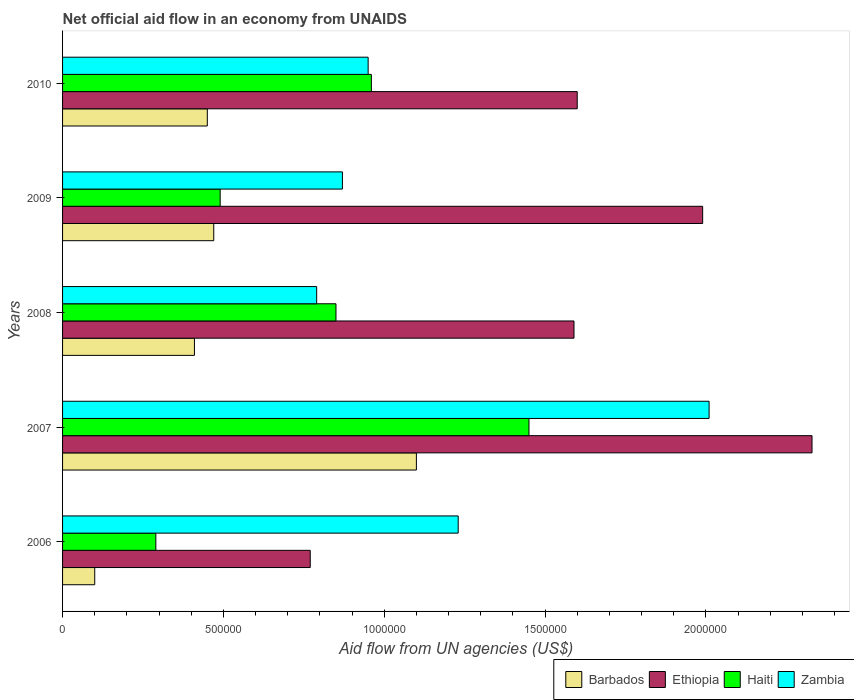How many different coloured bars are there?
Keep it short and to the point. 4. How many groups of bars are there?
Make the answer very short. 5. Are the number of bars on each tick of the Y-axis equal?
Your response must be concise. Yes. How many bars are there on the 1st tick from the bottom?
Your answer should be very brief. 4. What is the label of the 1st group of bars from the top?
Your response must be concise. 2010. What is the net official aid flow in Zambia in 2006?
Offer a very short reply. 1.23e+06. Across all years, what is the maximum net official aid flow in Barbados?
Make the answer very short. 1.10e+06. Across all years, what is the minimum net official aid flow in Zambia?
Provide a succinct answer. 7.90e+05. What is the total net official aid flow in Haiti in the graph?
Make the answer very short. 4.04e+06. What is the difference between the net official aid flow in Zambia in 2007 and that in 2008?
Ensure brevity in your answer.  1.22e+06. What is the difference between the net official aid flow in Ethiopia in 2009 and the net official aid flow in Zambia in 2007?
Your answer should be very brief. -2.00e+04. What is the average net official aid flow in Barbados per year?
Your answer should be compact. 5.06e+05. What is the ratio of the net official aid flow in Ethiopia in 2008 to that in 2009?
Your answer should be compact. 0.8. Is the difference between the net official aid flow in Haiti in 2009 and 2010 greater than the difference between the net official aid flow in Barbados in 2009 and 2010?
Your answer should be very brief. No. What is the difference between the highest and the second highest net official aid flow in Haiti?
Make the answer very short. 4.90e+05. What is the difference between the highest and the lowest net official aid flow in Ethiopia?
Keep it short and to the point. 1.56e+06. In how many years, is the net official aid flow in Ethiopia greater than the average net official aid flow in Ethiopia taken over all years?
Your answer should be very brief. 2. Is the sum of the net official aid flow in Barbados in 2006 and 2008 greater than the maximum net official aid flow in Zambia across all years?
Offer a terse response. No. Is it the case that in every year, the sum of the net official aid flow in Barbados and net official aid flow in Zambia is greater than the sum of net official aid flow in Ethiopia and net official aid flow in Haiti?
Keep it short and to the point. Yes. What does the 4th bar from the top in 2010 represents?
Ensure brevity in your answer.  Barbados. What does the 3rd bar from the bottom in 2010 represents?
Ensure brevity in your answer.  Haiti. How many bars are there?
Your response must be concise. 20. Are all the bars in the graph horizontal?
Provide a succinct answer. Yes. Are the values on the major ticks of X-axis written in scientific E-notation?
Your answer should be compact. No. Where does the legend appear in the graph?
Make the answer very short. Bottom right. How are the legend labels stacked?
Ensure brevity in your answer.  Horizontal. What is the title of the graph?
Make the answer very short. Net official aid flow in an economy from UNAIDS. What is the label or title of the X-axis?
Provide a short and direct response. Aid flow from UN agencies (US$). What is the label or title of the Y-axis?
Provide a succinct answer. Years. What is the Aid flow from UN agencies (US$) of Barbados in 2006?
Your answer should be very brief. 1.00e+05. What is the Aid flow from UN agencies (US$) of Ethiopia in 2006?
Make the answer very short. 7.70e+05. What is the Aid flow from UN agencies (US$) of Zambia in 2006?
Offer a very short reply. 1.23e+06. What is the Aid flow from UN agencies (US$) in Barbados in 2007?
Make the answer very short. 1.10e+06. What is the Aid flow from UN agencies (US$) of Ethiopia in 2007?
Provide a short and direct response. 2.33e+06. What is the Aid flow from UN agencies (US$) of Haiti in 2007?
Provide a short and direct response. 1.45e+06. What is the Aid flow from UN agencies (US$) of Zambia in 2007?
Ensure brevity in your answer.  2.01e+06. What is the Aid flow from UN agencies (US$) in Barbados in 2008?
Your answer should be compact. 4.10e+05. What is the Aid flow from UN agencies (US$) of Ethiopia in 2008?
Your answer should be compact. 1.59e+06. What is the Aid flow from UN agencies (US$) of Haiti in 2008?
Offer a terse response. 8.50e+05. What is the Aid flow from UN agencies (US$) of Zambia in 2008?
Your response must be concise. 7.90e+05. What is the Aid flow from UN agencies (US$) in Ethiopia in 2009?
Your answer should be compact. 1.99e+06. What is the Aid flow from UN agencies (US$) of Zambia in 2009?
Ensure brevity in your answer.  8.70e+05. What is the Aid flow from UN agencies (US$) of Barbados in 2010?
Ensure brevity in your answer.  4.50e+05. What is the Aid flow from UN agencies (US$) of Ethiopia in 2010?
Make the answer very short. 1.60e+06. What is the Aid flow from UN agencies (US$) in Haiti in 2010?
Your answer should be compact. 9.60e+05. What is the Aid flow from UN agencies (US$) in Zambia in 2010?
Your response must be concise. 9.50e+05. Across all years, what is the maximum Aid flow from UN agencies (US$) in Barbados?
Your answer should be very brief. 1.10e+06. Across all years, what is the maximum Aid flow from UN agencies (US$) of Ethiopia?
Offer a very short reply. 2.33e+06. Across all years, what is the maximum Aid flow from UN agencies (US$) of Haiti?
Provide a short and direct response. 1.45e+06. Across all years, what is the maximum Aid flow from UN agencies (US$) in Zambia?
Keep it short and to the point. 2.01e+06. Across all years, what is the minimum Aid flow from UN agencies (US$) in Barbados?
Provide a succinct answer. 1.00e+05. Across all years, what is the minimum Aid flow from UN agencies (US$) of Ethiopia?
Ensure brevity in your answer.  7.70e+05. Across all years, what is the minimum Aid flow from UN agencies (US$) in Haiti?
Keep it short and to the point. 2.90e+05. Across all years, what is the minimum Aid flow from UN agencies (US$) in Zambia?
Make the answer very short. 7.90e+05. What is the total Aid flow from UN agencies (US$) of Barbados in the graph?
Ensure brevity in your answer.  2.53e+06. What is the total Aid flow from UN agencies (US$) of Ethiopia in the graph?
Your response must be concise. 8.28e+06. What is the total Aid flow from UN agencies (US$) of Haiti in the graph?
Keep it short and to the point. 4.04e+06. What is the total Aid flow from UN agencies (US$) of Zambia in the graph?
Offer a terse response. 5.85e+06. What is the difference between the Aid flow from UN agencies (US$) of Barbados in 2006 and that in 2007?
Provide a succinct answer. -1.00e+06. What is the difference between the Aid flow from UN agencies (US$) in Ethiopia in 2006 and that in 2007?
Your answer should be compact. -1.56e+06. What is the difference between the Aid flow from UN agencies (US$) of Haiti in 2006 and that in 2007?
Provide a succinct answer. -1.16e+06. What is the difference between the Aid flow from UN agencies (US$) in Zambia in 2006 and that in 2007?
Your response must be concise. -7.80e+05. What is the difference between the Aid flow from UN agencies (US$) in Barbados in 2006 and that in 2008?
Your answer should be compact. -3.10e+05. What is the difference between the Aid flow from UN agencies (US$) in Ethiopia in 2006 and that in 2008?
Provide a succinct answer. -8.20e+05. What is the difference between the Aid flow from UN agencies (US$) of Haiti in 2006 and that in 2008?
Ensure brevity in your answer.  -5.60e+05. What is the difference between the Aid flow from UN agencies (US$) of Zambia in 2006 and that in 2008?
Provide a short and direct response. 4.40e+05. What is the difference between the Aid flow from UN agencies (US$) in Barbados in 2006 and that in 2009?
Offer a terse response. -3.70e+05. What is the difference between the Aid flow from UN agencies (US$) of Ethiopia in 2006 and that in 2009?
Provide a succinct answer. -1.22e+06. What is the difference between the Aid flow from UN agencies (US$) in Zambia in 2006 and that in 2009?
Your answer should be very brief. 3.60e+05. What is the difference between the Aid flow from UN agencies (US$) in Barbados in 2006 and that in 2010?
Make the answer very short. -3.50e+05. What is the difference between the Aid flow from UN agencies (US$) of Ethiopia in 2006 and that in 2010?
Offer a very short reply. -8.30e+05. What is the difference between the Aid flow from UN agencies (US$) of Haiti in 2006 and that in 2010?
Make the answer very short. -6.70e+05. What is the difference between the Aid flow from UN agencies (US$) in Barbados in 2007 and that in 2008?
Give a very brief answer. 6.90e+05. What is the difference between the Aid flow from UN agencies (US$) of Ethiopia in 2007 and that in 2008?
Keep it short and to the point. 7.40e+05. What is the difference between the Aid flow from UN agencies (US$) in Zambia in 2007 and that in 2008?
Your response must be concise. 1.22e+06. What is the difference between the Aid flow from UN agencies (US$) of Barbados in 2007 and that in 2009?
Ensure brevity in your answer.  6.30e+05. What is the difference between the Aid flow from UN agencies (US$) of Ethiopia in 2007 and that in 2009?
Provide a succinct answer. 3.40e+05. What is the difference between the Aid flow from UN agencies (US$) in Haiti in 2007 and that in 2009?
Ensure brevity in your answer.  9.60e+05. What is the difference between the Aid flow from UN agencies (US$) in Zambia in 2007 and that in 2009?
Ensure brevity in your answer.  1.14e+06. What is the difference between the Aid flow from UN agencies (US$) of Barbados in 2007 and that in 2010?
Your response must be concise. 6.50e+05. What is the difference between the Aid flow from UN agencies (US$) in Ethiopia in 2007 and that in 2010?
Provide a short and direct response. 7.30e+05. What is the difference between the Aid flow from UN agencies (US$) in Zambia in 2007 and that in 2010?
Ensure brevity in your answer.  1.06e+06. What is the difference between the Aid flow from UN agencies (US$) of Ethiopia in 2008 and that in 2009?
Offer a terse response. -4.00e+05. What is the difference between the Aid flow from UN agencies (US$) in Ethiopia in 2008 and that in 2010?
Ensure brevity in your answer.  -10000. What is the difference between the Aid flow from UN agencies (US$) in Haiti in 2008 and that in 2010?
Make the answer very short. -1.10e+05. What is the difference between the Aid flow from UN agencies (US$) in Zambia in 2008 and that in 2010?
Provide a succinct answer. -1.60e+05. What is the difference between the Aid flow from UN agencies (US$) in Barbados in 2009 and that in 2010?
Your answer should be compact. 2.00e+04. What is the difference between the Aid flow from UN agencies (US$) of Ethiopia in 2009 and that in 2010?
Make the answer very short. 3.90e+05. What is the difference between the Aid flow from UN agencies (US$) of Haiti in 2009 and that in 2010?
Provide a succinct answer. -4.70e+05. What is the difference between the Aid flow from UN agencies (US$) of Zambia in 2009 and that in 2010?
Make the answer very short. -8.00e+04. What is the difference between the Aid flow from UN agencies (US$) of Barbados in 2006 and the Aid flow from UN agencies (US$) of Ethiopia in 2007?
Your response must be concise. -2.23e+06. What is the difference between the Aid flow from UN agencies (US$) in Barbados in 2006 and the Aid flow from UN agencies (US$) in Haiti in 2007?
Keep it short and to the point. -1.35e+06. What is the difference between the Aid flow from UN agencies (US$) in Barbados in 2006 and the Aid flow from UN agencies (US$) in Zambia in 2007?
Ensure brevity in your answer.  -1.91e+06. What is the difference between the Aid flow from UN agencies (US$) in Ethiopia in 2006 and the Aid flow from UN agencies (US$) in Haiti in 2007?
Offer a very short reply. -6.80e+05. What is the difference between the Aid flow from UN agencies (US$) in Ethiopia in 2006 and the Aid flow from UN agencies (US$) in Zambia in 2007?
Ensure brevity in your answer.  -1.24e+06. What is the difference between the Aid flow from UN agencies (US$) in Haiti in 2006 and the Aid flow from UN agencies (US$) in Zambia in 2007?
Keep it short and to the point. -1.72e+06. What is the difference between the Aid flow from UN agencies (US$) in Barbados in 2006 and the Aid flow from UN agencies (US$) in Ethiopia in 2008?
Provide a short and direct response. -1.49e+06. What is the difference between the Aid flow from UN agencies (US$) in Barbados in 2006 and the Aid flow from UN agencies (US$) in Haiti in 2008?
Make the answer very short. -7.50e+05. What is the difference between the Aid flow from UN agencies (US$) in Barbados in 2006 and the Aid flow from UN agencies (US$) in Zambia in 2008?
Ensure brevity in your answer.  -6.90e+05. What is the difference between the Aid flow from UN agencies (US$) of Ethiopia in 2006 and the Aid flow from UN agencies (US$) of Zambia in 2008?
Make the answer very short. -2.00e+04. What is the difference between the Aid flow from UN agencies (US$) in Haiti in 2006 and the Aid flow from UN agencies (US$) in Zambia in 2008?
Provide a short and direct response. -5.00e+05. What is the difference between the Aid flow from UN agencies (US$) in Barbados in 2006 and the Aid flow from UN agencies (US$) in Ethiopia in 2009?
Your answer should be very brief. -1.89e+06. What is the difference between the Aid flow from UN agencies (US$) in Barbados in 2006 and the Aid flow from UN agencies (US$) in Haiti in 2009?
Keep it short and to the point. -3.90e+05. What is the difference between the Aid flow from UN agencies (US$) in Barbados in 2006 and the Aid flow from UN agencies (US$) in Zambia in 2009?
Give a very brief answer. -7.70e+05. What is the difference between the Aid flow from UN agencies (US$) in Ethiopia in 2006 and the Aid flow from UN agencies (US$) in Haiti in 2009?
Provide a short and direct response. 2.80e+05. What is the difference between the Aid flow from UN agencies (US$) of Ethiopia in 2006 and the Aid flow from UN agencies (US$) of Zambia in 2009?
Your answer should be very brief. -1.00e+05. What is the difference between the Aid flow from UN agencies (US$) of Haiti in 2006 and the Aid flow from UN agencies (US$) of Zambia in 2009?
Your response must be concise. -5.80e+05. What is the difference between the Aid flow from UN agencies (US$) in Barbados in 2006 and the Aid flow from UN agencies (US$) in Ethiopia in 2010?
Keep it short and to the point. -1.50e+06. What is the difference between the Aid flow from UN agencies (US$) of Barbados in 2006 and the Aid flow from UN agencies (US$) of Haiti in 2010?
Offer a terse response. -8.60e+05. What is the difference between the Aid flow from UN agencies (US$) in Barbados in 2006 and the Aid flow from UN agencies (US$) in Zambia in 2010?
Offer a very short reply. -8.50e+05. What is the difference between the Aid flow from UN agencies (US$) in Ethiopia in 2006 and the Aid flow from UN agencies (US$) in Haiti in 2010?
Offer a very short reply. -1.90e+05. What is the difference between the Aid flow from UN agencies (US$) of Haiti in 2006 and the Aid flow from UN agencies (US$) of Zambia in 2010?
Your answer should be very brief. -6.60e+05. What is the difference between the Aid flow from UN agencies (US$) in Barbados in 2007 and the Aid flow from UN agencies (US$) in Ethiopia in 2008?
Ensure brevity in your answer.  -4.90e+05. What is the difference between the Aid flow from UN agencies (US$) in Ethiopia in 2007 and the Aid flow from UN agencies (US$) in Haiti in 2008?
Offer a terse response. 1.48e+06. What is the difference between the Aid flow from UN agencies (US$) of Ethiopia in 2007 and the Aid flow from UN agencies (US$) of Zambia in 2008?
Provide a succinct answer. 1.54e+06. What is the difference between the Aid flow from UN agencies (US$) of Haiti in 2007 and the Aid flow from UN agencies (US$) of Zambia in 2008?
Ensure brevity in your answer.  6.60e+05. What is the difference between the Aid flow from UN agencies (US$) in Barbados in 2007 and the Aid flow from UN agencies (US$) in Ethiopia in 2009?
Your answer should be compact. -8.90e+05. What is the difference between the Aid flow from UN agencies (US$) of Ethiopia in 2007 and the Aid flow from UN agencies (US$) of Haiti in 2009?
Offer a very short reply. 1.84e+06. What is the difference between the Aid flow from UN agencies (US$) in Ethiopia in 2007 and the Aid flow from UN agencies (US$) in Zambia in 2009?
Offer a very short reply. 1.46e+06. What is the difference between the Aid flow from UN agencies (US$) of Haiti in 2007 and the Aid flow from UN agencies (US$) of Zambia in 2009?
Provide a short and direct response. 5.80e+05. What is the difference between the Aid flow from UN agencies (US$) of Barbados in 2007 and the Aid flow from UN agencies (US$) of Ethiopia in 2010?
Your answer should be compact. -5.00e+05. What is the difference between the Aid flow from UN agencies (US$) of Ethiopia in 2007 and the Aid flow from UN agencies (US$) of Haiti in 2010?
Give a very brief answer. 1.37e+06. What is the difference between the Aid flow from UN agencies (US$) of Ethiopia in 2007 and the Aid flow from UN agencies (US$) of Zambia in 2010?
Provide a succinct answer. 1.38e+06. What is the difference between the Aid flow from UN agencies (US$) in Barbados in 2008 and the Aid flow from UN agencies (US$) in Ethiopia in 2009?
Ensure brevity in your answer.  -1.58e+06. What is the difference between the Aid flow from UN agencies (US$) of Barbados in 2008 and the Aid flow from UN agencies (US$) of Haiti in 2009?
Your answer should be very brief. -8.00e+04. What is the difference between the Aid flow from UN agencies (US$) in Barbados in 2008 and the Aid flow from UN agencies (US$) in Zambia in 2009?
Your answer should be compact. -4.60e+05. What is the difference between the Aid flow from UN agencies (US$) in Ethiopia in 2008 and the Aid flow from UN agencies (US$) in Haiti in 2009?
Provide a short and direct response. 1.10e+06. What is the difference between the Aid flow from UN agencies (US$) of Ethiopia in 2008 and the Aid flow from UN agencies (US$) of Zambia in 2009?
Ensure brevity in your answer.  7.20e+05. What is the difference between the Aid flow from UN agencies (US$) in Barbados in 2008 and the Aid flow from UN agencies (US$) in Ethiopia in 2010?
Your response must be concise. -1.19e+06. What is the difference between the Aid flow from UN agencies (US$) in Barbados in 2008 and the Aid flow from UN agencies (US$) in Haiti in 2010?
Your response must be concise. -5.50e+05. What is the difference between the Aid flow from UN agencies (US$) of Barbados in 2008 and the Aid flow from UN agencies (US$) of Zambia in 2010?
Ensure brevity in your answer.  -5.40e+05. What is the difference between the Aid flow from UN agencies (US$) of Ethiopia in 2008 and the Aid flow from UN agencies (US$) of Haiti in 2010?
Make the answer very short. 6.30e+05. What is the difference between the Aid flow from UN agencies (US$) of Ethiopia in 2008 and the Aid flow from UN agencies (US$) of Zambia in 2010?
Your response must be concise. 6.40e+05. What is the difference between the Aid flow from UN agencies (US$) of Haiti in 2008 and the Aid flow from UN agencies (US$) of Zambia in 2010?
Your answer should be very brief. -1.00e+05. What is the difference between the Aid flow from UN agencies (US$) of Barbados in 2009 and the Aid flow from UN agencies (US$) of Ethiopia in 2010?
Keep it short and to the point. -1.13e+06. What is the difference between the Aid flow from UN agencies (US$) in Barbados in 2009 and the Aid flow from UN agencies (US$) in Haiti in 2010?
Provide a succinct answer. -4.90e+05. What is the difference between the Aid flow from UN agencies (US$) of Barbados in 2009 and the Aid flow from UN agencies (US$) of Zambia in 2010?
Ensure brevity in your answer.  -4.80e+05. What is the difference between the Aid flow from UN agencies (US$) of Ethiopia in 2009 and the Aid flow from UN agencies (US$) of Haiti in 2010?
Provide a succinct answer. 1.03e+06. What is the difference between the Aid flow from UN agencies (US$) in Ethiopia in 2009 and the Aid flow from UN agencies (US$) in Zambia in 2010?
Ensure brevity in your answer.  1.04e+06. What is the difference between the Aid flow from UN agencies (US$) of Haiti in 2009 and the Aid flow from UN agencies (US$) of Zambia in 2010?
Provide a short and direct response. -4.60e+05. What is the average Aid flow from UN agencies (US$) of Barbados per year?
Your answer should be very brief. 5.06e+05. What is the average Aid flow from UN agencies (US$) in Ethiopia per year?
Your answer should be very brief. 1.66e+06. What is the average Aid flow from UN agencies (US$) of Haiti per year?
Make the answer very short. 8.08e+05. What is the average Aid flow from UN agencies (US$) in Zambia per year?
Keep it short and to the point. 1.17e+06. In the year 2006, what is the difference between the Aid flow from UN agencies (US$) in Barbados and Aid flow from UN agencies (US$) in Ethiopia?
Keep it short and to the point. -6.70e+05. In the year 2006, what is the difference between the Aid flow from UN agencies (US$) of Barbados and Aid flow from UN agencies (US$) of Zambia?
Make the answer very short. -1.13e+06. In the year 2006, what is the difference between the Aid flow from UN agencies (US$) in Ethiopia and Aid flow from UN agencies (US$) in Zambia?
Your response must be concise. -4.60e+05. In the year 2006, what is the difference between the Aid flow from UN agencies (US$) of Haiti and Aid flow from UN agencies (US$) of Zambia?
Provide a succinct answer. -9.40e+05. In the year 2007, what is the difference between the Aid flow from UN agencies (US$) in Barbados and Aid flow from UN agencies (US$) in Ethiopia?
Ensure brevity in your answer.  -1.23e+06. In the year 2007, what is the difference between the Aid flow from UN agencies (US$) in Barbados and Aid flow from UN agencies (US$) in Haiti?
Make the answer very short. -3.50e+05. In the year 2007, what is the difference between the Aid flow from UN agencies (US$) of Barbados and Aid flow from UN agencies (US$) of Zambia?
Your response must be concise. -9.10e+05. In the year 2007, what is the difference between the Aid flow from UN agencies (US$) in Ethiopia and Aid flow from UN agencies (US$) in Haiti?
Provide a short and direct response. 8.80e+05. In the year 2007, what is the difference between the Aid flow from UN agencies (US$) of Ethiopia and Aid flow from UN agencies (US$) of Zambia?
Your answer should be very brief. 3.20e+05. In the year 2007, what is the difference between the Aid flow from UN agencies (US$) of Haiti and Aid flow from UN agencies (US$) of Zambia?
Provide a short and direct response. -5.60e+05. In the year 2008, what is the difference between the Aid flow from UN agencies (US$) in Barbados and Aid flow from UN agencies (US$) in Ethiopia?
Ensure brevity in your answer.  -1.18e+06. In the year 2008, what is the difference between the Aid flow from UN agencies (US$) of Barbados and Aid flow from UN agencies (US$) of Haiti?
Your response must be concise. -4.40e+05. In the year 2008, what is the difference between the Aid flow from UN agencies (US$) of Barbados and Aid flow from UN agencies (US$) of Zambia?
Your response must be concise. -3.80e+05. In the year 2008, what is the difference between the Aid flow from UN agencies (US$) in Ethiopia and Aid flow from UN agencies (US$) in Haiti?
Offer a very short reply. 7.40e+05. In the year 2009, what is the difference between the Aid flow from UN agencies (US$) of Barbados and Aid flow from UN agencies (US$) of Ethiopia?
Keep it short and to the point. -1.52e+06. In the year 2009, what is the difference between the Aid flow from UN agencies (US$) in Barbados and Aid flow from UN agencies (US$) in Zambia?
Keep it short and to the point. -4.00e+05. In the year 2009, what is the difference between the Aid flow from UN agencies (US$) in Ethiopia and Aid flow from UN agencies (US$) in Haiti?
Keep it short and to the point. 1.50e+06. In the year 2009, what is the difference between the Aid flow from UN agencies (US$) in Ethiopia and Aid flow from UN agencies (US$) in Zambia?
Keep it short and to the point. 1.12e+06. In the year 2009, what is the difference between the Aid flow from UN agencies (US$) in Haiti and Aid flow from UN agencies (US$) in Zambia?
Provide a succinct answer. -3.80e+05. In the year 2010, what is the difference between the Aid flow from UN agencies (US$) in Barbados and Aid flow from UN agencies (US$) in Ethiopia?
Ensure brevity in your answer.  -1.15e+06. In the year 2010, what is the difference between the Aid flow from UN agencies (US$) in Barbados and Aid flow from UN agencies (US$) in Haiti?
Ensure brevity in your answer.  -5.10e+05. In the year 2010, what is the difference between the Aid flow from UN agencies (US$) in Barbados and Aid flow from UN agencies (US$) in Zambia?
Offer a very short reply. -5.00e+05. In the year 2010, what is the difference between the Aid flow from UN agencies (US$) in Ethiopia and Aid flow from UN agencies (US$) in Haiti?
Offer a very short reply. 6.40e+05. In the year 2010, what is the difference between the Aid flow from UN agencies (US$) in Ethiopia and Aid flow from UN agencies (US$) in Zambia?
Ensure brevity in your answer.  6.50e+05. What is the ratio of the Aid flow from UN agencies (US$) in Barbados in 2006 to that in 2007?
Give a very brief answer. 0.09. What is the ratio of the Aid flow from UN agencies (US$) in Ethiopia in 2006 to that in 2007?
Ensure brevity in your answer.  0.33. What is the ratio of the Aid flow from UN agencies (US$) of Zambia in 2006 to that in 2007?
Provide a short and direct response. 0.61. What is the ratio of the Aid flow from UN agencies (US$) in Barbados in 2006 to that in 2008?
Ensure brevity in your answer.  0.24. What is the ratio of the Aid flow from UN agencies (US$) of Ethiopia in 2006 to that in 2008?
Give a very brief answer. 0.48. What is the ratio of the Aid flow from UN agencies (US$) in Haiti in 2006 to that in 2008?
Make the answer very short. 0.34. What is the ratio of the Aid flow from UN agencies (US$) in Zambia in 2006 to that in 2008?
Give a very brief answer. 1.56. What is the ratio of the Aid flow from UN agencies (US$) in Barbados in 2006 to that in 2009?
Your answer should be compact. 0.21. What is the ratio of the Aid flow from UN agencies (US$) of Ethiopia in 2006 to that in 2009?
Your answer should be very brief. 0.39. What is the ratio of the Aid flow from UN agencies (US$) in Haiti in 2006 to that in 2009?
Give a very brief answer. 0.59. What is the ratio of the Aid flow from UN agencies (US$) of Zambia in 2006 to that in 2009?
Your answer should be very brief. 1.41. What is the ratio of the Aid flow from UN agencies (US$) of Barbados in 2006 to that in 2010?
Your answer should be very brief. 0.22. What is the ratio of the Aid flow from UN agencies (US$) in Ethiopia in 2006 to that in 2010?
Keep it short and to the point. 0.48. What is the ratio of the Aid flow from UN agencies (US$) of Haiti in 2006 to that in 2010?
Ensure brevity in your answer.  0.3. What is the ratio of the Aid flow from UN agencies (US$) in Zambia in 2006 to that in 2010?
Your response must be concise. 1.29. What is the ratio of the Aid flow from UN agencies (US$) of Barbados in 2007 to that in 2008?
Provide a short and direct response. 2.68. What is the ratio of the Aid flow from UN agencies (US$) in Ethiopia in 2007 to that in 2008?
Your response must be concise. 1.47. What is the ratio of the Aid flow from UN agencies (US$) in Haiti in 2007 to that in 2008?
Your answer should be compact. 1.71. What is the ratio of the Aid flow from UN agencies (US$) of Zambia in 2007 to that in 2008?
Your answer should be compact. 2.54. What is the ratio of the Aid flow from UN agencies (US$) in Barbados in 2007 to that in 2009?
Your response must be concise. 2.34. What is the ratio of the Aid flow from UN agencies (US$) in Ethiopia in 2007 to that in 2009?
Provide a short and direct response. 1.17. What is the ratio of the Aid flow from UN agencies (US$) of Haiti in 2007 to that in 2009?
Make the answer very short. 2.96. What is the ratio of the Aid flow from UN agencies (US$) in Zambia in 2007 to that in 2009?
Your response must be concise. 2.31. What is the ratio of the Aid flow from UN agencies (US$) in Barbados in 2007 to that in 2010?
Offer a very short reply. 2.44. What is the ratio of the Aid flow from UN agencies (US$) in Ethiopia in 2007 to that in 2010?
Make the answer very short. 1.46. What is the ratio of the Aid flow from UN agencies (US$) of Haiti in 2007 to that in 2010?
Your answer should be very brief. 1.51. What is the ratio of the Aid flow from UN agencies (US$) in Zambia in 2007 to that in 2010?
Your response must be concise. 2.12. What is the ratio of the Aid flow from UN agencies (US$) in Barbados in 2008 to that in 2009?
Make the answer very short. 0.87. What is the ratio of the Aid flow from UN agencies (US$) of Ethiopia in 2008 to that in 2009?
Provide a short and direct response. 0.8. What is the ratio of the Aid flow from UN agencies (US$) in Haiti in 2008 to that in 2009?
Give a very brief answer. 1.73. What is the ratio of the Aid flow from UN agencies (US$) of Zambia in 2008 to that in 2009?
Your response must be concise. 0.91. What is the ratio of the Aid flow from UN agencies (US$) of Barbados in 2008 to that in 2010?
Provide a succinct answer. 0.91. What is the ratio of the Aid flow from UN agencies (US$) of Haiti in 2008 to that in 2010?
Your answer should be very brief. 0.89. What is the ratio of the Aid flow from UN agencies (US$) of Zambia in 2008 to that in 2010?
Your response must be concise. 0.83. What is the ratio of the Aid flow from UN agencies (US$) of Barbados in 2009 to that in 2010?
Keep it short and to the point. 1.04. What is the ratio of the Aid flow from UN agencies (US$) in Ethiopia in 2009 to that in 2010?
Provide a short and direct response. 1.24. What is the ratio of the Aid flow from UN agencies (US$) of Haiti in 2009 to that in 2010?
Give a very brief answer. 0.51. What is the ratio of the Aid flow from UN agencies (US$) in Zambia in 2009 to that in 2010?
Your response must be concise. 0.92. What is the difference between the highest and the second highest Aid flow from UN agencies (US$) of Barbados?
Give a very brief answer. 6.30e+05. What is the difference between the highest and the second highest Aid flow from UN agencies (US$) in Haiti?
Make the answer very short. 4.90e+05. What is the difference between the highest and the second highest Aid flow from UN agencies (US$) in Zambia?
Provide a short and direct response. 7.80e+05. What is the difference between the highest and the lowest Aid flow from UN agencies (US$) in Ethiopia?
Give a very brief answer. 1.56e+06. What is the difference between the highest and the lowest Aid flow from UN agencies (US$) of Haiti?
Offer a terse response. 1.16e+06. What is the difference between the highest and the lowest Aid flow from UN agencies (US$) in Zambia?
Your response must be concise. 1.22e+06. 